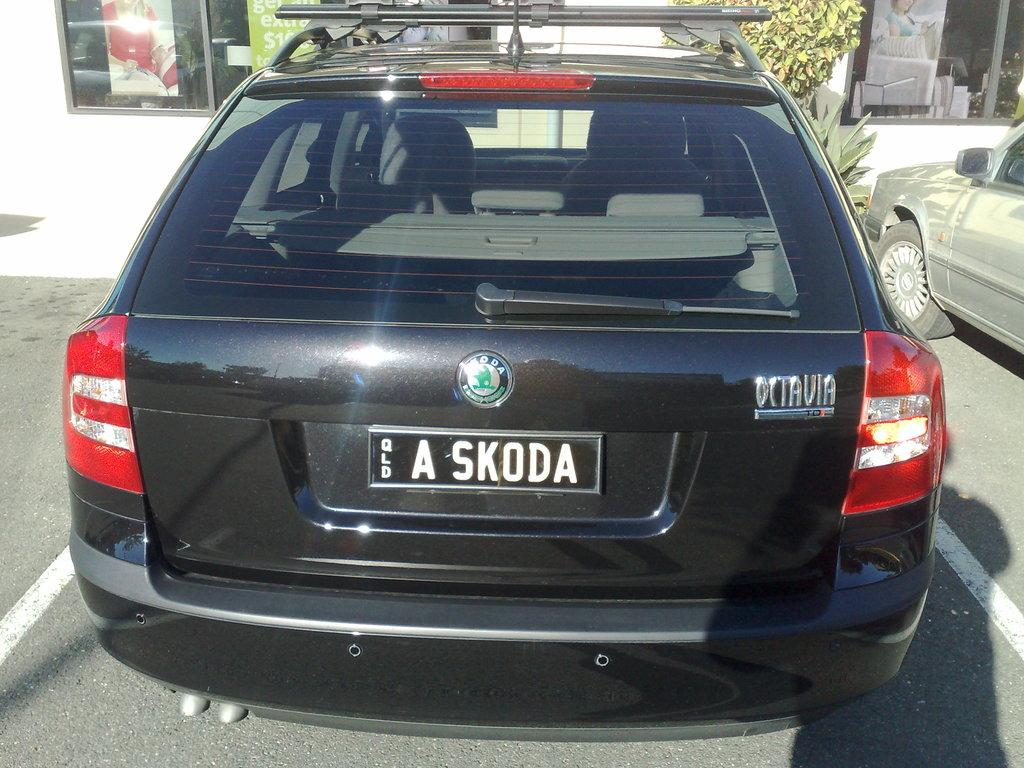<image>
Provide a brief description of the given image. BMW Station wagon from the back side view with number plate A Skoda. 